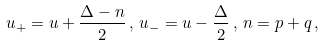<formula> <loc_0><loc_0><loc_500><loc_500>u _ { + } = u + \frac { \Delta - n } { 2 } \, , \, u _ { - } = u - \frac { \Delta } { 2 } \, , \, n = p + q \, ,</formula> 